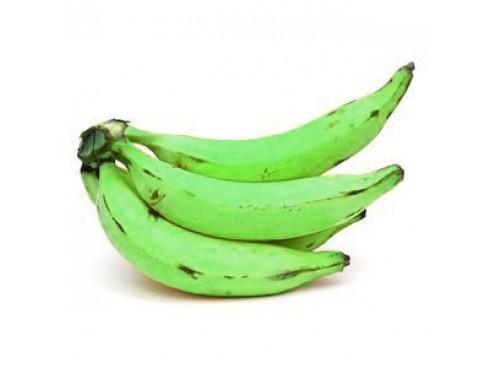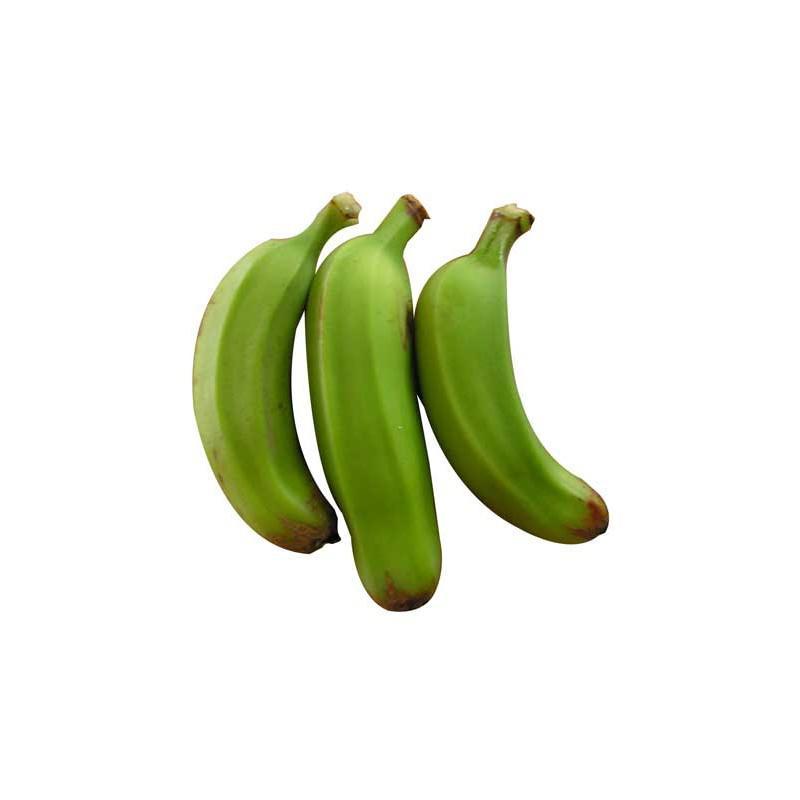The first image is the image on the left, the second image is the image on the right. Assess this claim about the two images: "One of the images is exactly three green bananas, and this particular bunch is not connected.". Correct or not? Answer yes or no. Yes. 